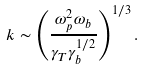<formula> <loc_0><loc_0><loc_500><loc_500>k \sim \left ( \frac { \omega _ { p } ^ { 2 } \omega _ { b } } { \gamma _ { T } \gamma _ { b } ^ { 1 / 2 } } \right ) ^ { 1 / 3 } .</formula> 